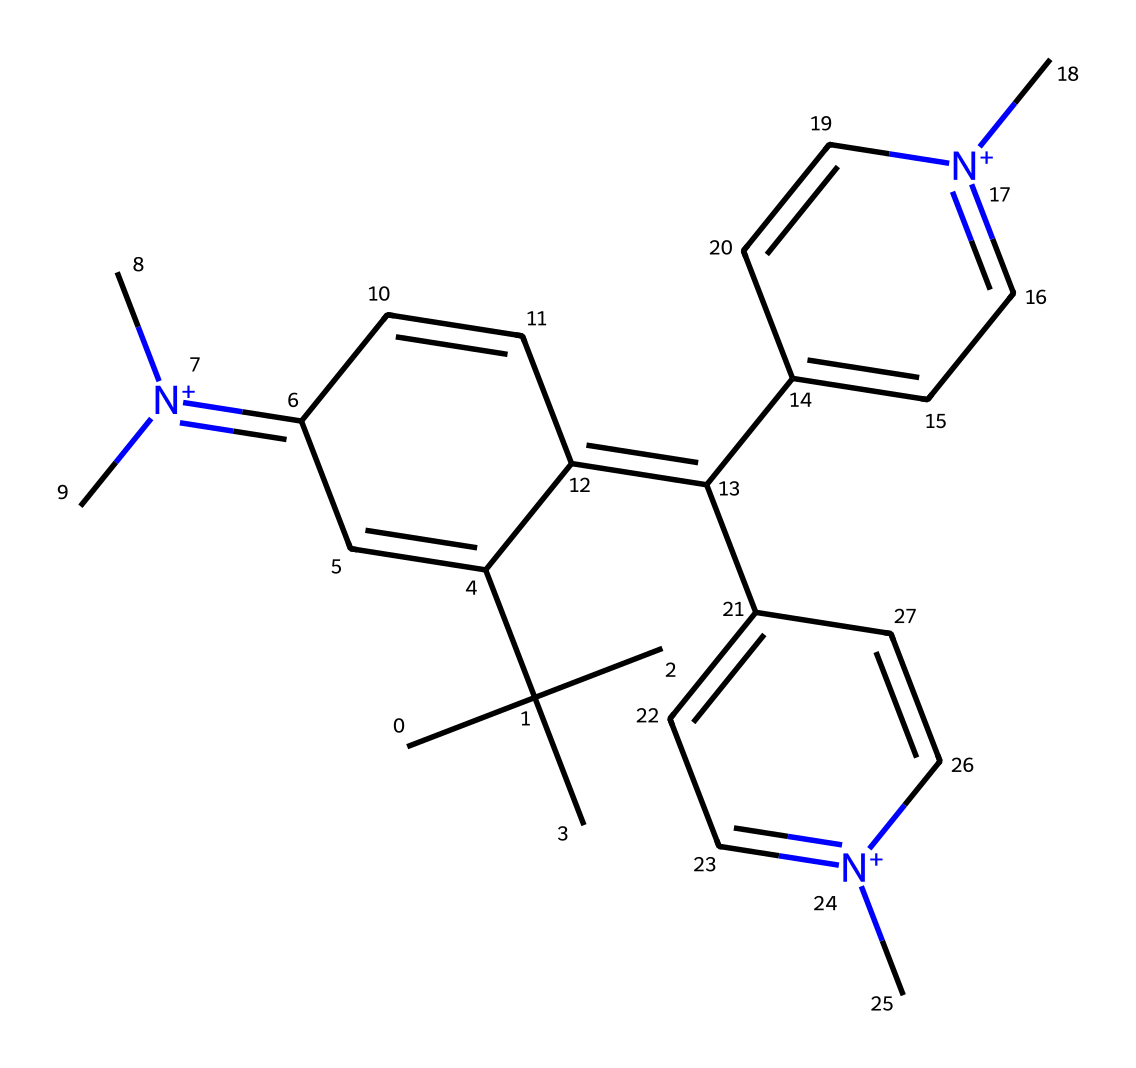What is the molecular formula of crystal violet? To determine the molecular formula, we analyze the SMILES representation to count each type of atom. By evaluating the structure, we can identify that there are 27 carbons, 30 hydrogens, and 3 nitrogens in the chemical. Therefore, the molecular formula is C25H30N3.
Answer: C25H30N3 How many nitrogen atoms are present in crystal violet? By examining the SMILES representation, we can see there are three nitrogen atoms in the structure, indicated by the presence of [N+] groups.
Answer: 3 Is crystal violet a cationic or anionic dye? Given that the structure contains positively charged nitrogen atoms, which are denoted by [N+], this indicates that it behaves as a cationic dye. Cationic dyes typically carry a positive charge at physiological pH.
Answer: cationic What color is crystal violet in solution? Crystal violet is known for its intense purple color when dissolved in solution, which is characteristic of many dyes in the triarylmethane class.
Answer: purple Which functional groups are present in crystal violet? The primary functional groups in crystal violet include the triarylmethane structure, which consists of aromatic rings and positively charged nitrogen atoms, defining its properties as a dye.
Answer: triarylmethane How many aromatic rings does crystal violet contain? By analyzing the structure, we can identify three distinct aromatic rings within the triarylmethane framework of crystal violet. Each ring is integral to its coloring properties.
Answer: 3 What is the primary application of crystal violet in microbiology? Crystal violet is commonly used in microbiology for Gram staining, which allows for the differentiation of bacterial species based on the characteristics of their cell walls.
Answer: Gram staining 